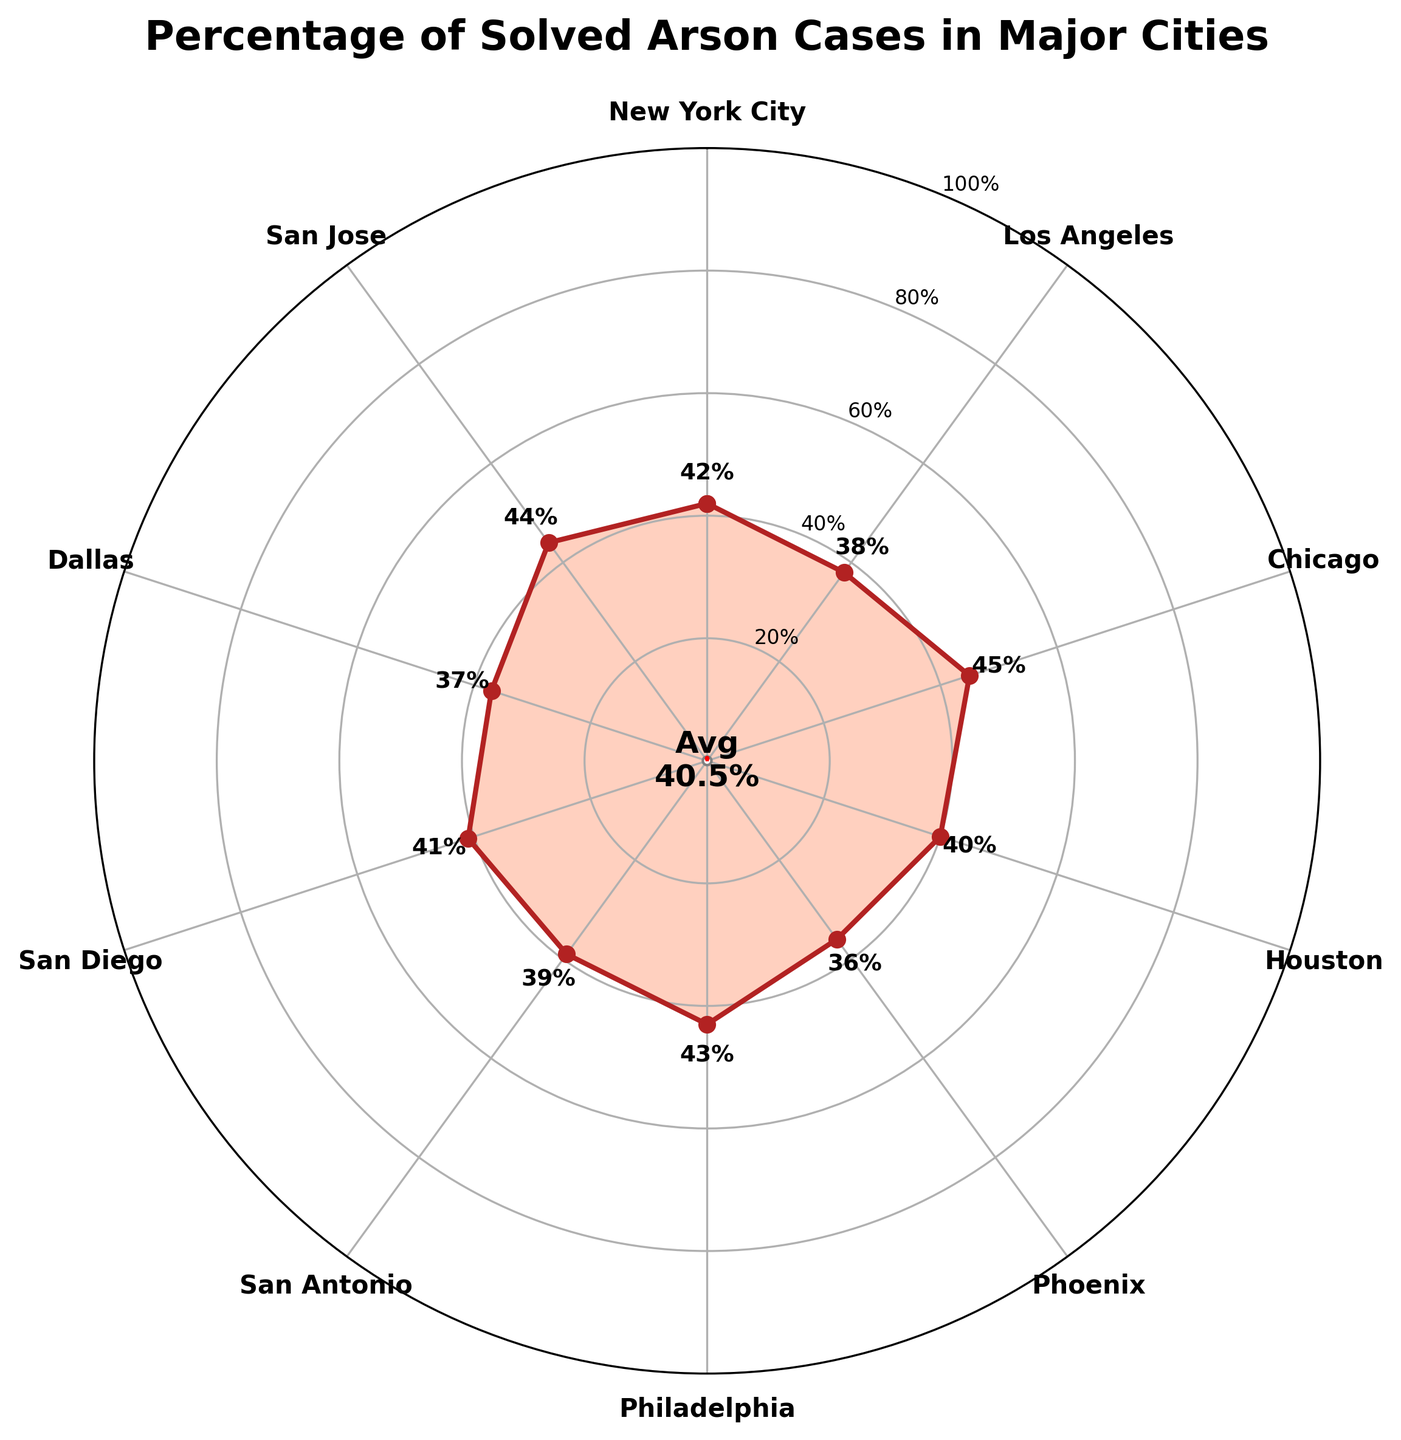What city has the highest percentage of solved arson cases? Look for the city with the highest percentage value on the plot. San Jose has the highest percentage at 44%.
Answer: San Jose What is the average percentage of solved arson cases across all cities? Sum the percentages for all cities, then divide by the number of cities (10). The sum is (42 + 38 + 45 + 40 + 36 + 43 + 39 + 41 + 37 + 44) = 405, so the average is 405/10 = 40.5
Answer: 40.5 Which two cities have the closest percentages of solved arson cases? Look for cities with percentages that are numerically close to each other. New York City (42%) and San Diego (41%) are the closest.
Answer: New York City and San Diego How many cities have a percentage of solved arson cases above 40%? Count the number of cities where the percentage is greater than 40%. Cities with percentages above 40% are New York City (42%), Chicago (45%), Philadelphia (43%), San Diego (41%), and San Jose (44%). There are 5 such cities.
Answer: 5 Which city has the lowest percentage of solved arson cases? Look for the city with the lowest percentage value on the plot. Phoenix has the lowest percentage at 36%.
Answer: Phoenix What is the median percentage of solved arson cases across all cities? Arrange the percentages in numerical order and find the middle value. Ordered percentages: (36, 37, 38, 39, 40, 41, 42, 43, 44, 45). The median is the average of the 5th and 6th values (40 and 41), so the median is (40 + 41)/2 = 40.5
Answer: 40.5 What is the difference in the percentage of solved arson cases between New York City and Phoenix? Calculate the difference between the percentages for New York City (42%) and Phoenix (36%). The difference is 42 - 36 = 6.
Answer: 6 Which cities have a percentage of solved arson cases exactly equal to the average percentage across all cities? First, calculate the average (previously found: 40.5). No city has exactly 40.5%, but cities close to this are Houston (40%), and San Diego (41%).
Answer: None What is the total percentage of solved arson cases for the three cities with the highest percentages? Identify the three cities with the highest percentages: Chicago (45%), San Jose (44%), and Philadelphia (43%). Sum these percentages: 45 + 44 + 43 = 132.
Answer: 132 How does the percentage of solved arson cases in Los Angeles compare to that in Dallas? Compare the percentages directly: Los Angeles (38%) and Dallas (37%). Los Angeles has a 1% higher percentage than Dallas.
Answer: Los Angeles is 1% higher 